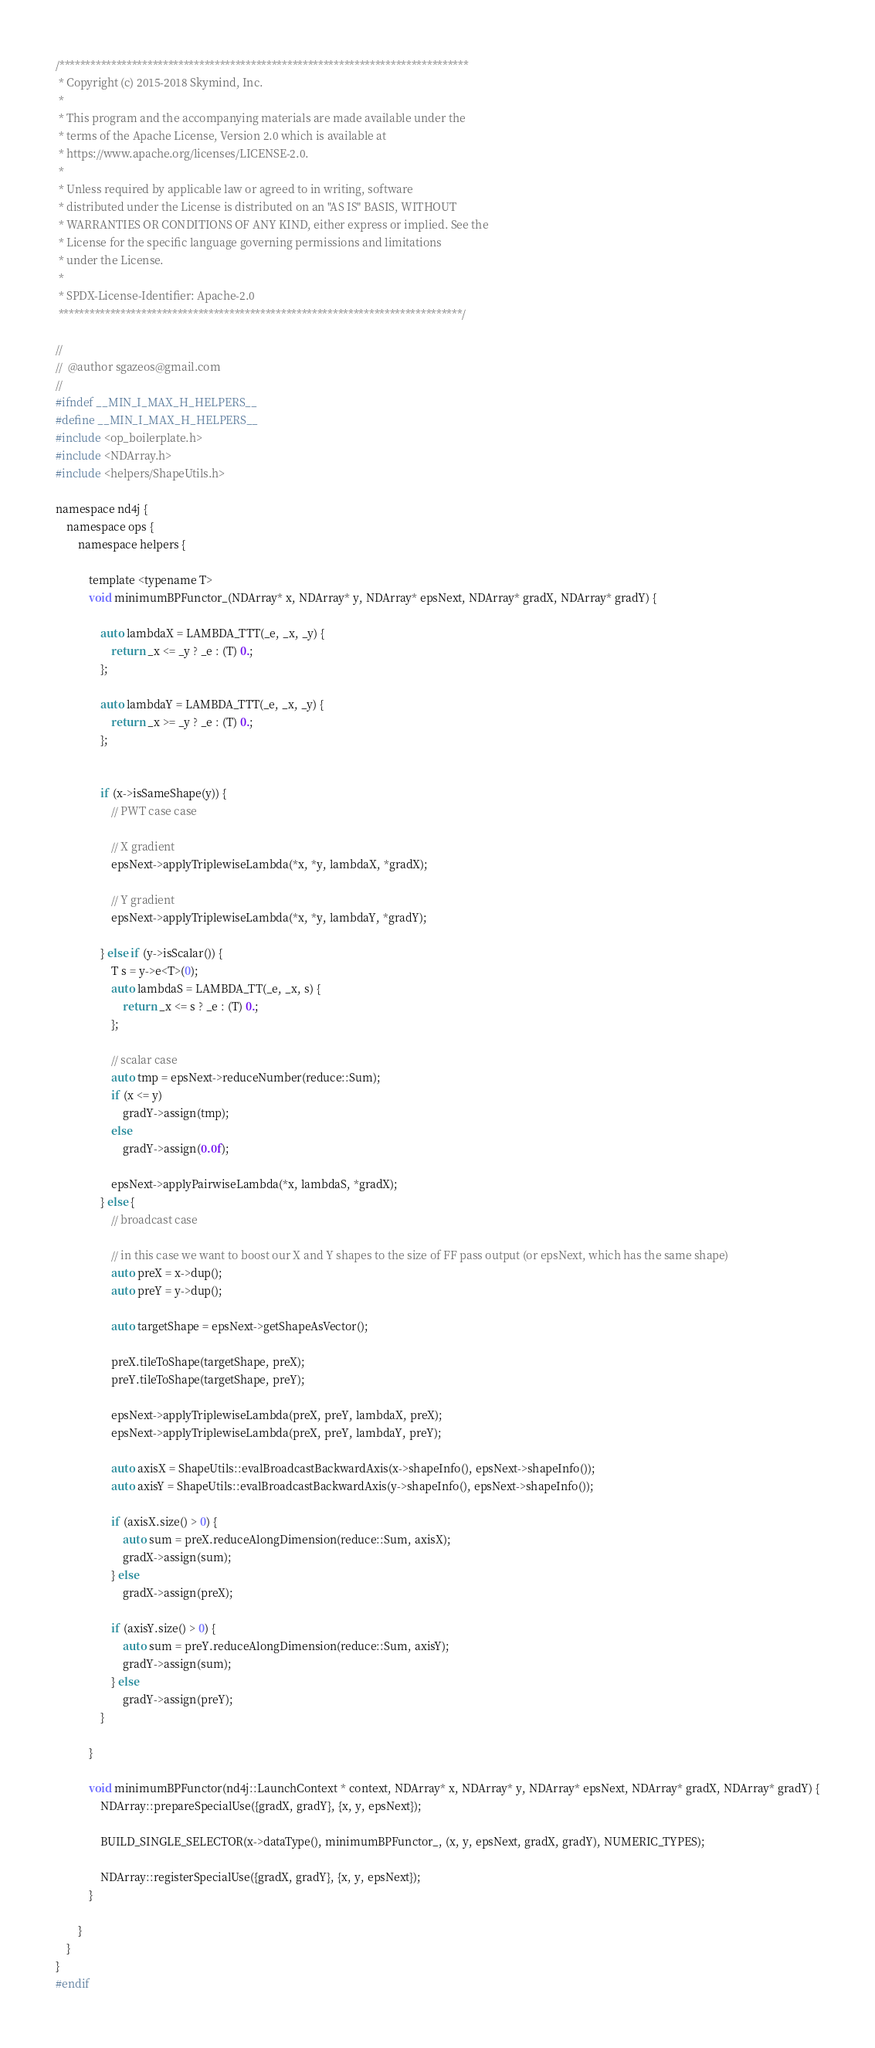<code> <loc_0><loc_0><loc_500><loc_500><_Cuda_>/*******************************************************************************
 * Copyright (c) 2015-2018 Skymind, Inc.
 *
 * This program and the accompanying materials are made available under the
 * terms of the Apache License, Version 2.0 which is available at
 * https://www.apache.org/licenses/LICENSE-2.0.
 *
 * Unless required by applicable law or agreed to in writing, software
 * distributed under the License is distributed on an "AS IS" BASIS, WITHOUT
 * WARRANTIES OR CONDITIONS OF ANY KIND, either express or implied. See the
 * License for the specific language governing permissions and limitations
 * under the License.
 *
 * SPDX-License-Identifier: Apache-2.0
 ******************************************************************************/

//
//  @author sgazeos@gmail.com
//
#ifndef __MIN_I_MAX_H_HELPERS__
#define __MIN_I_MAX_H_HELPERS__
#include <op_boilerplate.h>
#include <NDArray.h>
#include <helpers/ShapeUtils.h>

namespace nd4j {
    namespace ops {
        namespace helpers {

            template <typename T>
            void minimumBPFunctor_(NDArray* x, NDArray* y, NDArray* epsNext, NDArray* gradX, NDArray* gradY) {

                auto lambdaX = LAMBDA_TTT(_e, _x, _y) {
                    return _x <= _y ? _e : (T) 0.;
                };

                auto lambdaY = LAMBDA_TTT(_e, _x, _y) {
                    return _x >= _y ? _e : (T) 0.;
                };


                if (x->isSameShape(y)) {
                    // PWT case case

                    // X gradient
                    epsNext->applyTriplewiseLambda(*x, *y, lambdaX, *gradX);

                    // Y gradient
                    epsNext->applyTriplewiseLambda(*x, *y, lambdaY, *gradY);

                } else if (y->isScalar()) {
                    T s = y->e<T>(0);
                    auto lambdaS = LAMBDA_TT(_e, _x, s) {
                        return _x <= s ? _e : (T) 0.;
                    };

                    // scalar case
                    auto tmp = epsNext->reduceNumber(reduce::Sum);
                    if (x <= y)
                        gradY->assign(tmp);
                    else
                        gradY->assign(0.0f);

                    epsNext->applyPairwiseLambda(*x, lambdaS, *gradX);
                } else {
                    // broadcast case

                    // in this case we want to boost our X and Y shapes to the size of FF pass output (or epsNext, which has the same shape)
                    auto preX = x->dup();
                    auto preY = y->dup();

                    auto targetShape = epsNext->getShapeAsVector();

                    preX.tileToShape(targetShape, preX);
                    preY.tileToShape(targetShape, preY);

                    epsNext->applyTriplewiseLambda(preX, preY, lambdaX, preX);
                    epsNext->applyTriplewiseLambda(preX, preY, lambdaY, preY);

                    auto axisX = ShapeUtils::evalBroadcastBackwardAxis(x->shapeInfo(), epsNext->shapeInfo());
                    auto axisY = ShapeUtils::evalBroadcastBackwardAxis(y->shapeInfo(), epsNext->shapeInfo());

                    if (axisX.size() > 0) {
                        auto sum = preX.reduceAlongDimension(reduce::Sum, axisX);
                        gradX->assign(sum);
                    } else
                        gradX->assign(preX);

                    if (axisY.size() > 0) {
                        auto sum = preY.reduceAlongDimension(reduce::Sum, axisY);
                        gradY->assign(sum);
                    } else
                        gradY->assign(preY);
                }

            }

            void minimumBPFunctor(nd4j::LaunchContext * context, NDArray* x, NDArray* y, NDArray* epsNext, NDArray* gradX, NDArray* gradY) {
                NDArray::prepareSpecialUse({gradX, gradY}, {x, y, epsNext});

                BUILD_SINGLE_SELECTOR(x->dataType(), minimumBPFunctor_, (x, y, epsNext, gradX, gradY), NUMERIC_TYPES);

                NDArray::registerSpecialUse({gradX, gradY}, {x, y, epsNext});
            }

        }
    }
}
#endif
</code> 